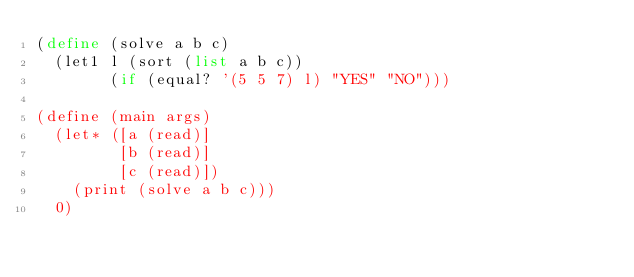Convert code to text. <code><loc_0><loc_0><loc_500><loc_500><_Scheme_>(define (solve a b c)
  (let1 l (sort (list a b c))
        (if (equal? '(5 5 7) l) "YES" "NO")))

(define (main args)
  (let* ([a (read)]
         [b (read)]
         [c (read)])
    (print (solve a b c)))
  0)
</code> 